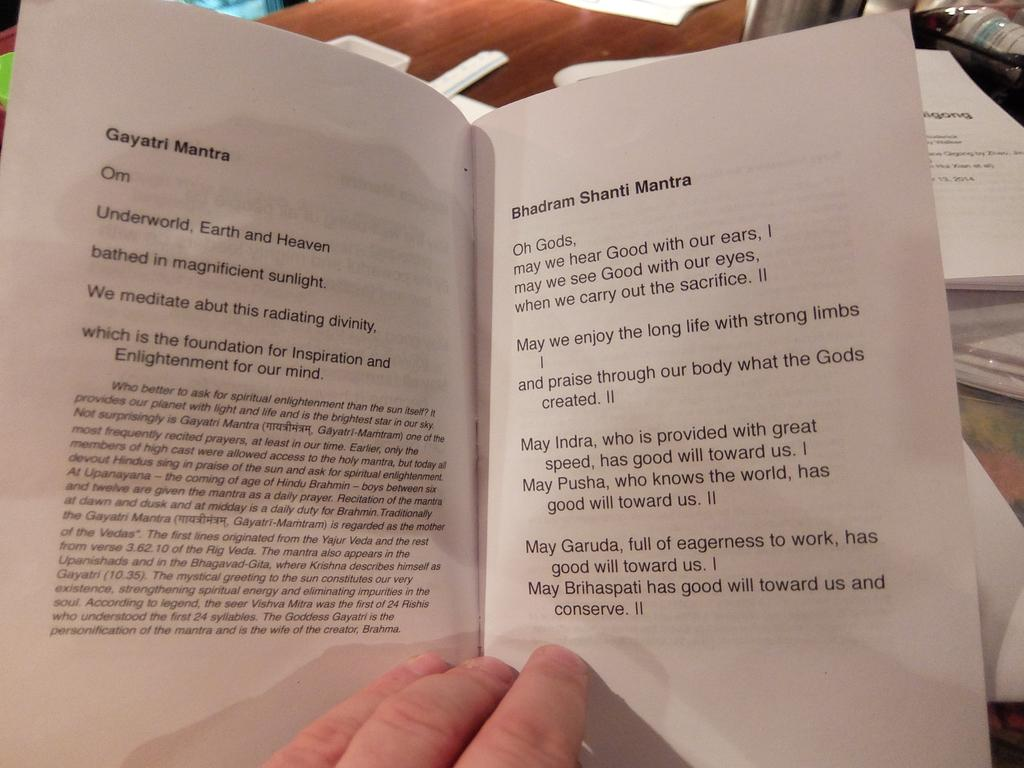Provide a one-sentence caption for the provided image. A book open to Gayatri Mantra and Bhadram Shanti Mantra pages. 